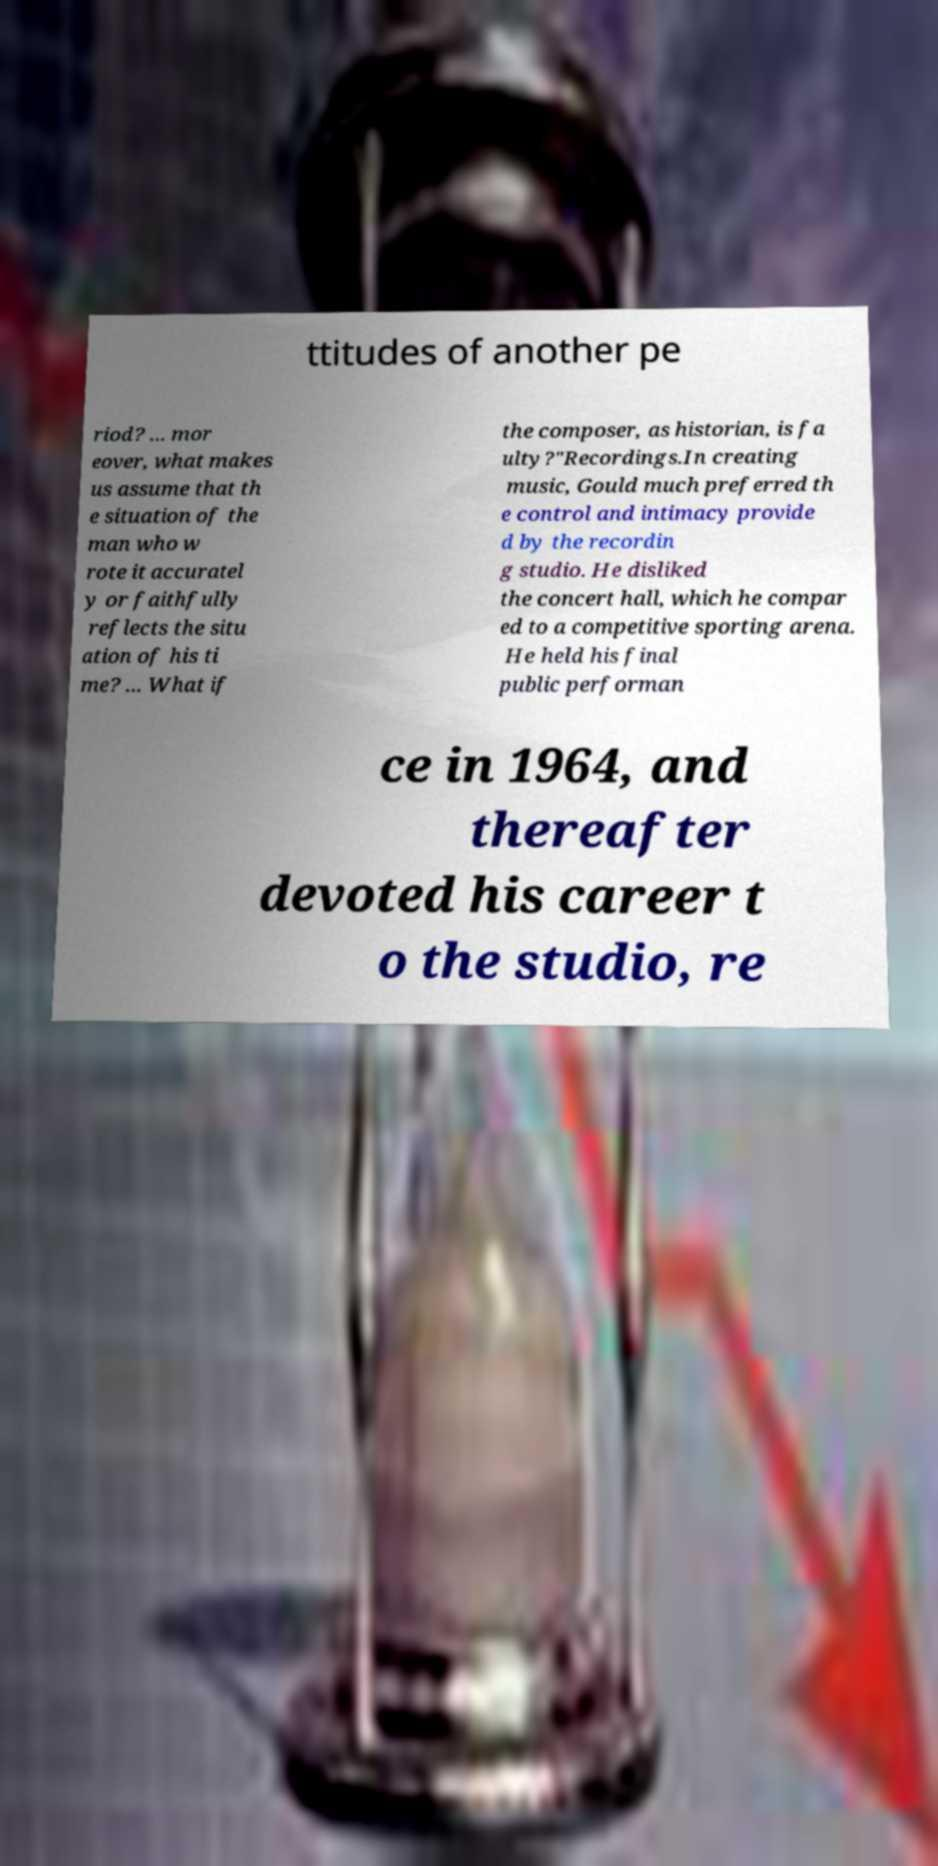Please identify and transcribe the text found in this image. ttitudes of another pe riod? ... mor eover, what makes us assume that th e situation of the man who w rote it accuratel y or faithfully reflects the situ ation of his ti me? ... What if the composer, as historian, is fa ulty?"Recordings.In creating music, Gould much preferred th e control and intimacy provide d by the recordin g studio. He disliked the concert hall, which he compar ed to a competitive sporting arena. He held his final public performan ce in 1964, and thereafter devoted his career t o the studio, re 